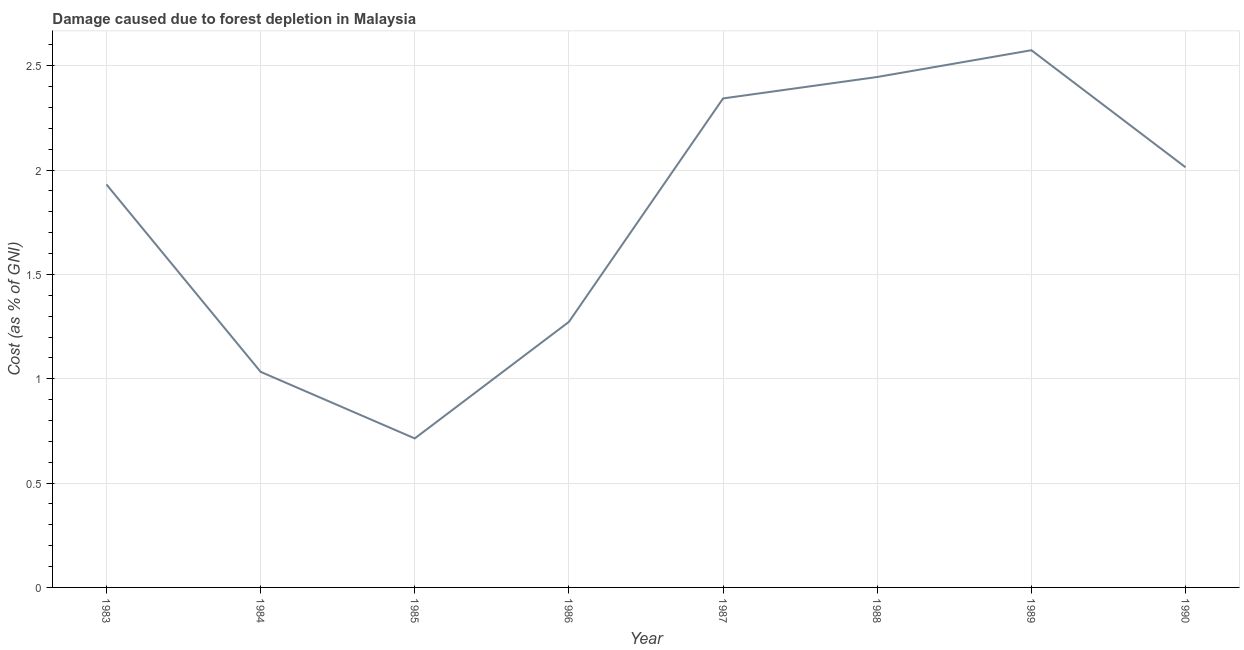What is the damage caused due to forest depletion in 1983?
Provide a succinct answer. 1.93. Across all years, what is the maximum damage caused due to forest depletion?
Offer a terse response. 2.57. Across all years, what is the minimum damage caused due to forest depletion?
Make the answer very short. 0.71. In which year was the damage caused due to forest depletion minimum?
Your answer should be compact. 1985. What is the sum of the damage caused due to forest depletion?
Your response must be concise. 14.33. What is the difference between the damage caused due to forest depletion in 1984 and 1987?
Give a very brief answer. -1.31. What is the average damage caused due to forest depletion per year?
Your answer should be very brief. 1.79. What is the median damage caused due to forest depletion?
Your answer should be compact. 1.97. Do a majority of the years between 1987 and 1983 (inclusive) have damage caused due to forest depletion greater than 1.9 %?
Keep it short and to the point. Yes. What is the ratio of the damage caused due to forest depletion in 1985 to that in 1987?
Make the answer very short. 0.3. Is the damage caused due to forest depletion in 1985 less than that in 1988?
Offer a terse response. Yes. What is the difference between the highest and the second highest damage caused due to forest depletion?
Make the answer very short. 0.13. Is the sum of the damage caused due to forest depletion in 1985 and 1989 greater than the maximum damage caused due to forest depletion across all years?
Give a very brief answer. Yes. What is the difference between the highest and the lowest damage caused due to forest depletion?
Offer a very short reply. 1.86. How many lines are there?
Provide a short and direct response. 1. Does the graph contain any zero values?
Offer a very short reply. No. What is the title of the graph?
Ensure brevity in your answer.  Damage caused due to forest depletion in Malaysia. What is the label or title of the Y-axis?
Your answer should be compact. Cost (as % of GNI). What is the Cost (as % of GNI) in 1983?
Your answer should be very brief. 1.93. What is the Cost (as % of GNI) of 1984?
Your answer should be very brief. 1.03. What is the Cost (as % of GNI) of 1985?
Provide a succinct answer. 0.71. What is the Cost (as % of GNI) in 1986?
Your answer should be compact. 1.27. What is the Cost (as % of GNI) of 1987?
Your answer should be very brief. 2.34. What is the Cost (as % of GNI) in 1988?
Ensure brevity in your answer.  2.45. What is the Cost (as % of GNI) in 1989?
Provide a short and direct response. 2.57. What is the Cost (as % of GNI) in 1990?
Provide a short and direct response. 2.01. What is the difference between the Cost (as % of GNI) in 1983 and 1984?
Offer a terse response. 0.9. What is the difference between the Cost (as % of GNI) in 1983 and 1985?
Offer a terse response. 1.22. What is the difference between the Cost (as % of GNI) in 1983 and 1986?
Ensure brevity in your answer.  0.66. What is the difference between the Cost (as % of GNI) in 1983 and 1987?
Ensure brevity in your answer.  -0.41. What is the difference between the Cost (as % of GNI) in 1983 and 1988?
Provide a succinct answer. -0.52. What is the difference between the Cost (as % of GNI) in 1983 and 1989?
Offer a very short reply. -0.64. What is the difference between the Cost (as % of GNI) in 1983 and 1990?
Keep it short and to the point. -0.08. What is the difference between the Cost (as % of GNI) in 1984 and 1985?
Offer a very short reply. 0.32. What is the difference between the Cost (as % of GNI) in 1984 and 1986?
Keep it short and to the point. -0.24. What is the difference between the Cost (as % of GNI) in 1984 and 1987?
Offer a terse response. -1.31. What is the difference between the Cost (as % of GNI) in 1984 and 1988?
Offer a terse response. -1.41. What is the difference between the Cost (as % of GNI) in 1984 and 1989?
Provide a short and direct response. -1.54. What is the difference between the Cost (as % of GNI) in 1984 and 1990?
Provide a succinct answer. -0.98. What is the difference between the Cost (as % of GNI) in 1985 and 1986?
Make the answer very short. -0.56. What is the difference between the Cost (as % of GNI) in 1985 and 1987?
Provide a succinct answer. -1.63. What is the difference between the Cost (as % of GNI) in 1985 and 1988?
Your answer should be compact. -1.73. What is the difference between the Cost (as % of GNI) in 1985 and 1989?
Give a very brief answer. -1.86. What is the difference between the Cost (as % of GNI) in 1985 and 1990?
Your answer should be very brief. -1.3. What is the difference between the Cost (as % of GNI) in 1986 and 1987?
Give a very brief answer. -1.07. What is the difference between the Cost (as % of GNI) in 1986 and 1988?
Provide a succinct answer. -1.17. What is the difference between the Cost (as % of GNI) in 1986 and 1989?
Your response must be concise. -1.3. What is the difference between the Cost (as % of GNI) in 1986 and 1990?
Make the answer very short. -0.74. What is the difference between the Cost (as % of GNI) in 1987 and 1988?
Ensure brevity in your answer.  -0.1. What is the difference between the Cost (as % of GNI) in 1987 and 1989?
Provide a succinct answer. -0.23. What is the difference between the Cost (as % of GNI) in 1987 and 1990?
Your answer should be compact. 0.33. What is the difference between the Cost (as % of GNI) in 1988 and 1989?
Your answer should be very brief. -0.13. What is the difference between the Cost (as % of GNI) in 1988 and 1990?
Provide a succinct answer. 0.43. What is the difference between the Cost (as % of GNI) in 1989 and 1990?
Provide a short and direct response. 0.56. What is the ratio of the Cost (as % of GNI) in 1983 to that in 1984?
Your answer should be very brief. 1.87. What is the ratio of the Cost (as % of GNI) in 1983 to that in 1985?
Offer a terse response. 2.71. What is the ratio of the Cost (as % of GNI) in 1983 to that in 1986?
Your answer should be compact. 1.52. What is the ratio of the Cost (as % of GNI) in 1983 to that in 1987?
Make the answer very short. 0.82. What is the ratio of the Cost (as % of GNI) in 1983 to that in 1988?
Provide a succinct answer. 0.79. What is the ratio of the Cost (as % of GNI) in 1983 to that in 1989?
Offer a terse response. 0.75. What is the ratio of the Cost (as % of GNI) in 1984 to that in 1985?
Provide a succinct answer. 1.45. What is the ratio of the Cost (as % of GNI) in 1984 to that in 1986?
Your response must be concise. 0.81. What is the ratio of the Cost (as % of GNI) in 1984 to that in 1987?
Make the answer very short. 0.44. What is the ratio of the Cost (as % of GNI) in 1984 to that in 1988?
Keep it short and to the point. 0.42. What is the ratio of the Cost (as % of GNI) in 1984 to that in 1989?
Provide a succinct answer. 0.4. What is the ratio of the Cost (as % of GNI) in 1984 to that in 1990?
Offer a terse response. 0.51. What is the ratio of the Cost (as % of GNI) in 1985 to that in 1986?
Provide a short and direct response. 0.56. What is the ratio of the Cost (as % of GNI) in 1985 to that in 1987?
Offer a very short reply. 0.3. What is the ratio of the Cost (as % of GNI) in 1985 to that in 1988?
Provide a succinct answer. 0.29. What is the ratio of the Cost (as % of GNI) in 1985 to that in 1989?
Provide a succinct answer. 0.28. What is the ratio of the Cost (as % of GNI) in 1985 to that in 1990?
Offer a very short reply. 0.35. What is the ratio of the Cost (as % of GNI) in 1986 to that in 1987?
Your answer should be very brief. 0.54. What is the ratio of the Cost (as % of GNI) in 1986 to that in 1988?
Provide a short and direct response. 0.52. What is the ratio of the Cost (as % of GNI) in 1986 to that in 1989?
Keep it short and to the point. 0.49. What is the ratio of the Cost (as % of GNI) in 1986 to that in 1990?
Offer a terse response. 0.63. What is the ratio of the Cost (as % of GNI) in 1987 to that in 1988?
Give a very brief answer. 0.96. What is the ratio of the Cost (as % of GNI) in 1987 to that in 1989?
Give a very brief answer. 0.91. What is the ratio of the Cost (as % of GNI) in 1987 to that in 1990?
Make the answer very short. 1.16. What is the ratio of the Cost (as % of GNI) in 1988 to that in 1989?
Ensure brevity in your answer.  0.95. What is the ratio of the Cost (as % of GNI) in 1988 to that in 1990?
Your response must be concise. 1.22. What is the ratio of the Cost (as % of GNI) in 1989 to that in 1990?
Provide a succinct answer. 1.28. 